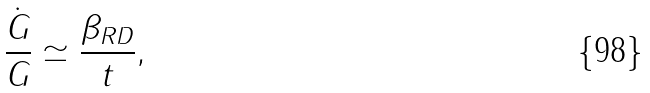<formula> <loc_0><loc_0><loc_500><loc_500>\frac { \dot { G } } { G } \simeq \frac { \beta _ { R D } } { t } ,</formula> 